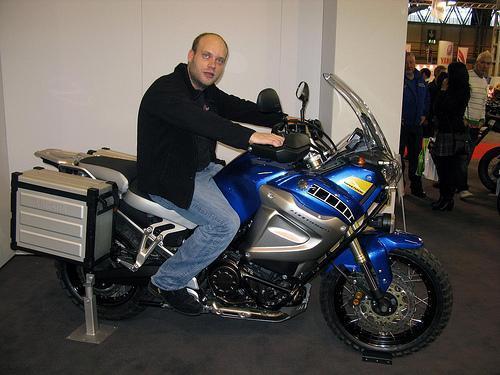How many motorcycles are there?
Give a very brief answer. 1. 